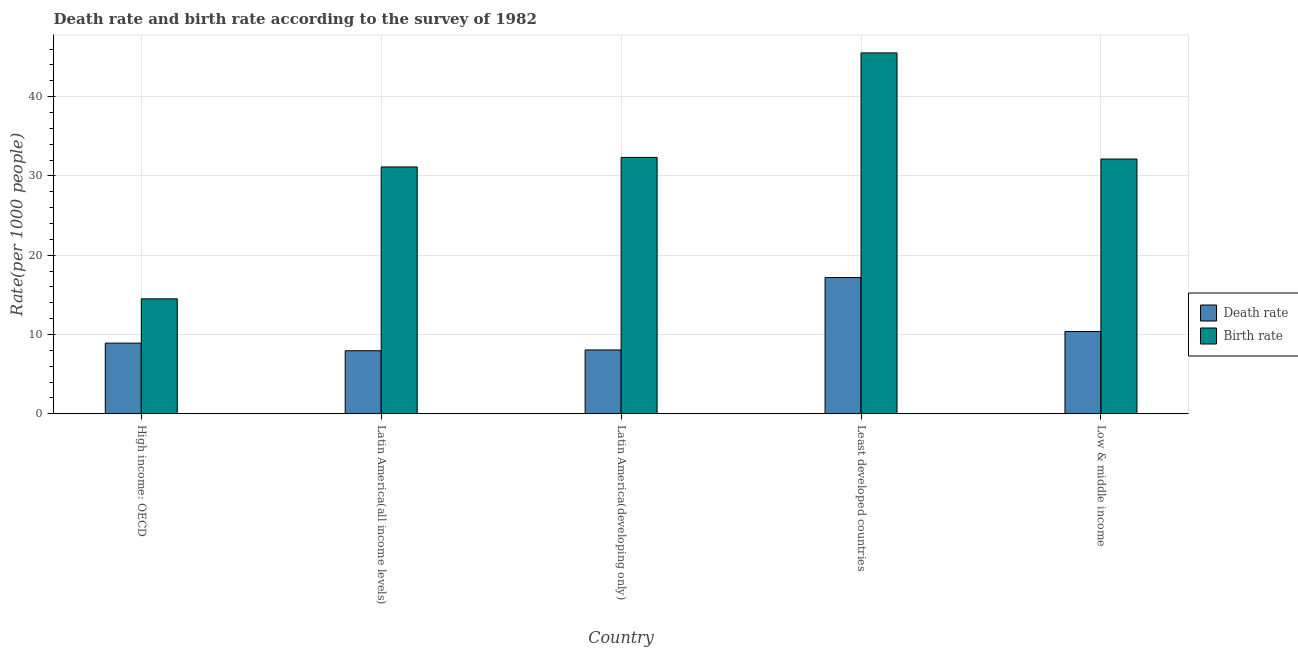Are the number of bars on each tick of the X-axis equal?
Provide a short and direct response. Yes. How many bars are there on the 4th tick from the left?
Provide a short and direct response. 2. What is the label of the 3rd group of bars from the left?
Your answer should be compact. Latin America(developing only). In how many cases, is the number of bars for a given country not equal to the number of legend labels?
Give a very brief answer. 0. What is the death rate in Low & middle income?
Make the answer very short. 10.37. Across all countries, what is the maximum birth rate?
Provide a short and direct response. 45.51. Across all countries, what is the minimum death rate?
Provide a short and direct response. 7.95. In which country was the birth rate maximum?
Your response must be concise. Least developed countries. In which country was the death rate minimum?
Your answer should be compact. Latin America(all income levels). What is the total death rate in the graph?
Your answer should be very brief. 52.45. What is the difference between the birth rate in High income: OECD and that in Latin America(developing only)?
Provide a succinct answer. -17.84. What is the difference between the death rate in Latin America(all income levels) and the birth rate in Least developed countries?
Your response must be concise. -37.57. What is the average birth rate per country?
Keep it short and to the point. 31.12. What is the difference between the death rate and birth rate in High income: OECD?
Provide a succinct answer. -5.59. In how many countries, is the birth rate greater than 28 ?
Offer a very short reply. 4. What is the ratio of the death rate in Latin America(developing only) to that in Least developed countries?
Your response must be concise. 0.47. Is the death rate in High income: OECD less than that in Least developed countries?
Your response must be concise. Yes. What is the difference between the highest and the second highest birth rate?
Offer a very short reply. 13.18. What is the difference between the highest and the lowest birth rate?
Keep it short and to the point. 31.02. In how many countries, is the birth rate greater than the average birth rate taken over all countries?
Provide a succinct answer. 4. What does the 1st bar from the left in Latin America(developing only) represents?
Offer a very short reply. Death rate. What does the 1st bar from the right in Latin America(developing only) represents?
Make the answer very short. Birth rate. How many bars are there?
Provide a succinct answer. 10. Are all the bars in the graph horizontal?
Provide a short and direct response. No. What is the difference between two consecutive major ticks on the Y-axis?
Make the answer very short. 10. Does the graph contain grids?
Provide a succinct answer. Yes. How many legend labels are there?
Your answer should be compact. 2. How are the legend labels stacked?
Your answer should be compact. Vertical. What is the title of the graph?
Your response must be concise. Death rate and birth rate according to the survey of 1982. Does "Private credit bureau" appear as one of the legend labels in the graph?
Offer a terse response. No. What is the label or title of the X-axis?
Your response must be concise. Country. What is the label or title of the Y-axis?
Give a very brief answer. Rate(per 1000 people). What is the Rate(per 1000 people) of Death rate in High income: OECD?
Provide a succinct answer. 8.91. What is the Rate(per 1000 people) in Birth rate in High income: OECD?
Your answer should be very brief. 14.49. What is the Rate(per 1000 people) of Death rate in Latin America(all income levels)?
Provide a succinct answer. 7.95. What is the Rate(per 1000 people) in Birth rate in Latin America(all income levels)?
Your response must be concise. 31.13. What is the Rate(per 1000 people) of Death rate in Latin America(developing only)?
Your answer should be compact. 8.05. What is the Rate(per 1000 people) of Birth rate in Latin America(developing only)?
Make the answer very short. 32.33. What is the Rate(per 1000 people) in Death rate in Least developed countries?
Offer a terse response. 17.18. What is the Rate(per 1000 people) in Birth rate in Least developed countries?
Offer a terse response. 45.51. What is the Rate(per 1000 people) in Death rate in Low & middle income?
Provide a short and direct response. 10.37. What is the Rate(per 1000 people) in Birth rate in Low & middle income?
Offer a terse response. 32.13. Across all countries, what is the maximum Rate(per 1000 people) of Death rate?
Your answer should be compact. 17.18. Across all countries, what is the maximum Rate(per 1000 people) in Birth rate?
Give a very brief answer. 45.51. Across all countries, what is the minimum Rate(per 1000 people) in Death rate?
Provide a short and direct response. 7.95. Across all countries, what is the minimum Rate(per 1000 people) of Birth rate?
Give a very brief answer. 14.49. What is the total Rate(per 1000 people) in Death rate in the graph?
Keep it short and to the point. 52.45. What is the total Rate(per 1000 people) in Birth rate in the graph?
Give a very brief answer. 155.6. What is the difference between the Rate(per 1000 people) of Death rate in High income: OECD and that in Latin America(all income levels)?
Provide a succinct answer. 0.96. What is the difference between the Rate(per 1000 people) of Birth rate in High income: OECD and that in Latin America(all income levels)?
Your answer should be very brief. -16.64. What is the difference between the Rate(per 1000 people) of Death rate in High income: OECD and that in Latin America(developing only)?
Ensure brevity in your answer.  0.86. What is the difference between the Rate(per 1000 people) in Birth rate in High income: OECD and that in Latin America(developing only)?
Keep it short and to the point. -17.84. What is the difference between the Rate(per 1000 people) in Death rate in High income: OECD and that in Least developed countries?
Ensure brevity in your answer.  -8.27. What is the difference between the Rate(per 1000 people) in Birth rate in High income: OECD and that in Least developed countries?
Keep it short and to the point. -31.02. What is the difference between the Rate(per 1000 people) of Death rate in High income: OECD and that in Low & middle income?
Your answer should be very brief. -1.47. What is the difference between the Rate(per 1000 people) in Birth rate in High income: OECD and that in Low & middle income?
Your response must be concise. -17.64. What is the difference between the Rate(per 1000 people) in Death rate in Latin America(all income levels) and that in Latin America(developing only)?
Provide a succinct answer. -0.1. What is the difference between the Rate(per 1000 people) in Birth rate in Latin America(all income levels) and that in Latin America(developing only)?
Provide a succinct answer. -1.2. What is the difference between the Rate(per 1000 people) in Death rate in Latin America(all income levels) and that in Least developed countries?
Your answer should be very brief. -9.23. What is the difference between the Rate(per 1000 people) of Birth rate in Latin America(all income levels) and that in Least developed countries?
Give a very brief answer. -14.38. What is the difference between the Rate(per 1000 people) in Death rate in Latin America(all income levels) and that in Low & middle income?
Provide a short and direct response. -2.43. What is the difference between the Rate(per 1000 people) in Birth rate in Latin America(all income levels) and that in Low & middle income?
Your answer should be very brief. -1. What is the difference between the Rate(per 1000 people) in Death rate in Latin America(developing only) and that in Least developed countries?
Give a very brief answer. -9.13. What is the difference between the Rate(per 1000 people) in Birth rate in Latin America(developing only) and that in Least developed countries?
Make the answer very short. -13.18. What is the difference between the Rate(per 1000 people) in Death rate in Latin America(developing only) and that in Low & middle income?
Your answer should be compact. -2.33. What is the difference between the Rate(per 1000 people) in Birth rate in Latin America(developing only) and that in Low & middle income?
Your answer should be very brief. 0.2. What is the difference between the Rate(per 1000 people) in Death rate in Least developed countries and that in Low & middle income?
Keep it short and to the point. 6.8. What is the difference between the Rate(per 1000 people) in Birth rate in Least developed countries and that in Low & middle income?
Make the answer very short. 13.39. What is the difference between the Rate(per 1000 people) of Death rate in High income: OECD and the Rate(per 1000 people) of Birth rate in Latin America(all income levels)?
Offer a terse response. -22.23. What is the difference between the Rate(per 1000 people) in Death rate in High income: OECD and the Rate(per 1000 people) in Birth rate in Latin America(developing only)?
Provide a succinct answer. -23.43. What is the difference between the Rate(per 1000 people) of Death rate in High income: OECD and the Rate(per 1000 people) of Birth rate in Least developed countries?
Make the answer very short. -36.61. What is the difference between the Rate(per 1000 people) of Death rate in High income: OECD and the Rate(per 1000 people) of Birth rate in Low & middle income?
Give a very brief answer. -23.22. What is the difference between the Rate(per 1000 people) in Death rate in Latin America(all income levels) and the Rate(per 1000 people) in Birth rate in Latin America(developing only)?
Ensure brevity in your answer.  -24.38. What is the difference between the Rate(per 1000 people) in Death rate in Latin America(all income levels) and the Rate(per 1000 people) in Birth rate in Least developed countries?
Your answer should be very brief. -37.57. What is the difference between the Rate(per 1000 people) in Death rate in Latin America(all income levels) and the Rate(per 1000 people) in Birth rate in Low & middle income?
Your response must be concise. -24.18. What is the difference between the Rate(per 1000 people) of Death rate in Latin America(developing only) and the Rate(per 1000 people) of Birth rate in Least developed countries?
Your answer should be very brief. -37.47. What is the difference between the Rate(per 1000 people) in Death rate in Latin America(developing only) and the Rate(per 1000 people) in Birth rate in Low & middle income?
Offer a terse response. -24.08. What is the difference between the Rate(per 1000 people) in Death rate in Least developed countries and the Rate(per 1000 people) in Birth rate in Low & middle income?
Make the answer very short. -14.95. What is the average Rate(per 1000 people) in Death rate per country?
Your response must be concise. 10.49. What is the average Rate(per 1000 people) of Birth rate per country?
Your answer should be compact. 31.12. What is the difference between the Rate(per 1000 people) in Death rate and Rate(per 1000 people) in Birth rate in High income: OECD?
Ensure brevity in your answer.  -5.59. What is the difference between the Rate(per 1000 people) of Death rate and Rate(per 1000 people) of Birth rate in Latin America(all income levels)?
Ensure brevity in your answer.  -23.18. What is the difference between the Rate(per 1000 people) in Death rate and Rate(per 1000 people) in Birth rate in Latin America(developing only)?
Offer a very short reply. -24.28. What is the difference between the Rate(per 1000 people) in Death rate and Rate(per 1000 people) in Birth rate in Least developed countries?
Your answer should be compact. -28.34. What is the difference between the Rate(per 1000 people) of Death rate and Rate(per 1000 people) of Birth rate in Low & middle income?
Offer a terse response. -21.76. What is the ratio of the Rate(per 1000 people) of Death rate in High income: OECD to that in Latin America(all income levels)?
Give a very brief answer. 1.12. What is the ratio of the Rate(per 1000 people) in Birth rate in High income: OECD to that in Latin America(all income levels)?
Provide a succinct answer. 0.47. What is the ratio of the Rate(per 1000 people) of Death rate in High income: OECD to that in Latin America(developing only)?
Your response must be concise. 1.11. What is the ratio of the Rate(per 1000 people) of Birth rate in High income: OECD to that in Latin America(developing only)?
Ensure brevity in your answer.  0.45. What is the ratio of the Rate(per 1000 people) in Death rate in High income: OECD to that in Least developed countries?
Provide a short and direct response. 0.52. What is the ratio of the Rate(per 1000 people) of Birth rate in High income: OECD to that in Least developed countries?
Offer a very short reply. 0.32. What is the ratio of the Rate(per 1000 people) of Death rate in High income: OECD to that in Low & middle income?
Offer a very short reply. 0.86. What is the ratio of the Rate(per 1000 people) in Birth rate in High income: OECD to that in Low & middle income?
Provide a succinct answer. 0.45. What is the ratio of the Rate(per 1000 people) of Death rate in Latin America(all income levels) to that in Latin America(developing only)?
Your answer should be compact. 0.99. What is the ratio of the Rate(per 1000 people) in Birth rate in Latin America(all income levels) to that in Latin America(developing only)?
Make the answer very short. 0.96. What is the ratio of the Rate(per 1000 people) of Death rate in Latin America(all income levels) to that in Least developed countries?
Make the answer very short. 0.46. What is the ratio of the Rate(per 1000 people) of Birth rate in Latin America(all income levels) to that in Least developed countries?
Offer a very short reply. 0.68. What is the ratio of the Rate(per 1000 people) of Death rate in Latin America(all income levels) to that in Low & middle income?
Give a very brief answer. 0.77. What is the ratio of the Rate(per 1000 people) of Birth rate in Latin America(all income levels) to that in Low & middle income?
Offer a terse response. 0.97. What is the ratio of the Rate(per 1000 people) in Death rate in Latin America(developing only) to that in Least developed countries?
Keep it short and to the point. 0.47. What is the ratio of the Rate(per 1000 people) of Birth rate in Latin America(developing only) to that in Least developed countries?
Your answer should be compact. 0.71. What is the ratio of the Rate(per 1000 people) in Death rate in Latin America(developing only) to that in Low & middle income?
Give a very brief answer. 0.78. What is the ratio of the Rate(per 1000 people) in Death rate in Least developed countries to that in Low & middle income?
Your response must be concise. 1.66. What is the ratio of the Rate(per 1000 people) of Birth rate in Least developed countries to that in Low & middle income?
Provide a succinct answer. 1.42. What is the difference between the highest and the second highest Rate(per 1000 people) of Death rate?
Ensure brevity in your answer.  6.8. What is the difference between the highest and the second highest Rate(per 1000 people) of Birth rate?
Your response must be concise. 13.18. What is the difference between the highest and the lowest Rate(per 1000 people) of Death rate?
Your answer should be compact. 9.23. What is the difference between the highest and the lowest Rate(per 1000 people) in Birth rate?
Keep it short and to the point. 31.02. 